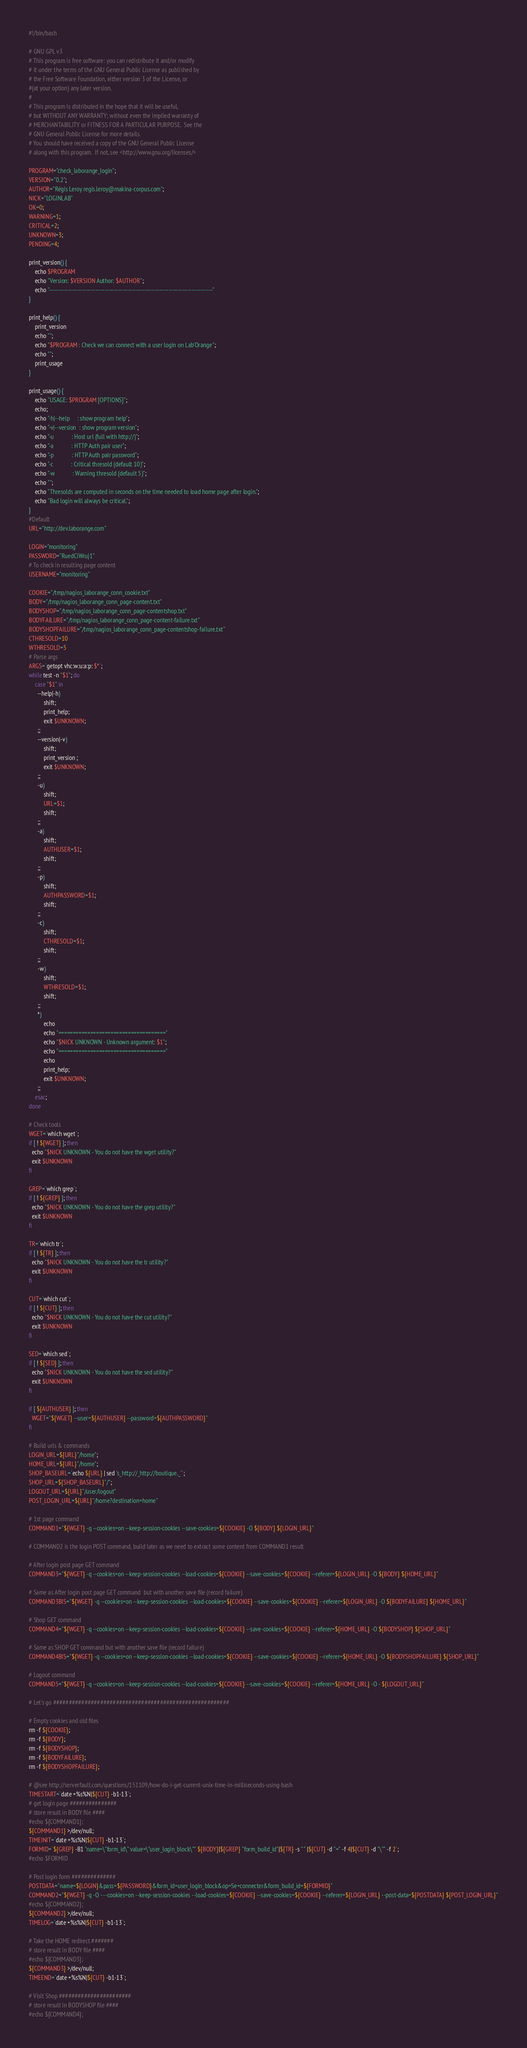<code> <loc_0><loc_0><loc_500><loc_500><_Bash_>#!/bin/bash

# GNU GPL v3
# This program is free software: you can redistribute it and/or modify
# it under the terms of the GNU General Public License as published by
# the Free Software Foundation, either version 3 of the License, or
#(at your option) any later version.
#
# This program is distributed in the hope that it will be useful,
# but WITHOUT ANY WARRANTY; without even the implied warranty of
# MERCHANTABILITY or FITNESS FOR A PARTICULAR PURPOSE.  See the
# GNU General Public License for more details.
# You should have received a copy of the GNU General Public License
# along with this program.  If not, see <http://www.gnu.org/licenses/>

PROGRAM="check_laborange_login";
VERSION="0.2";
AUTHOR="Régis Leroy regis.leroy@makina-corpus.com";
NICK="LOGINLAB"
OK=0;
WARNING=1;
CRITICAL=2;
UNKNOWN=3;
PENDING=4;

print_version() {
    echo $PROGRAM
    echo "Version: $VERSION Author: $AUTHOR";
    echo "-------------------------------------------------------------------------------------"
}

print_help() {
    print_version
    echo "";
    echo "$PROGRAM : Check we can connect with a user login on Lab'Orange";
    echo "";
    print_usage
}

print_usage() {
    echo "USAGE: $PROGRAM [OPTIONS]";
    echo;
    echo "-h|--help     : show program help";
    echo "-v|--version  : show program version";
    echo "-u            : Host url (full with http://)";
    echo "-a            : HTTP Auth pair user";
    echo "-p            : HTTP Auth pair password";
    echo "-c            : Critical thresold (default 10)";
    echo "-w            : Warning thresold (default 5)";
    echo "";
    echo "Thresolds are computed in seconds on the time needed to load home page after login.";
    echo "Bad login will always be critical.";
}
#Default
URL="http://dev.laborange.com"

LOGIN="monitoring"
PASSWORD="RuedCiWruj1"
# To check in resulting page content
USERNAME="monitoring"

COOKIE="/tmp/nagios_laborange_conn_cookie.txt"
BODY="/tmp/nagios_laborange_conn_page-content.txt"
BODYSHOP="/tmp/nagios_laborange_conn_page-contentshop.txt"
BODYFAILURE="/tmp/nagios_laborange_conn_page-content-failure.txt"
BODYSHOPFAILURE="/tmp/nagios_laborange_conn_page-contentshop-failure.txt"
CTHRESOLD=10
WTHRESOLD=5
# Parse args
ARGS=`getopt vhc:w:u:a:p: $*`;
while test -n "$1"; do
    case "$1" in
      --help|-h)
          shift;
          print_help;
          exit $UNKNOWN;
      ;;
      --version|-v)
          shift;
          print_version ;
          exit $UNKNOWN;
      ;;
      -u)
          shift;
          URL=$1;
          shift;
      ;;
      -a)
          shift;
          AUTHUSER=$1;
          shift;
      ;;
      -p)
          shift;
          AUTHPASSWORD=$1;
          shift;
      ;;
      -c)
          shift;
          CTHRESOLD=$1;
          shift;
      ;;
      -w)
          shift;
          WTHRESOLD=$1;
          shift;
      ;;
      *)
          echo 
          echo "====================================="
          echo "$NICK UNKNOWN - Unknown argument: $1";
          echo "====================================="
          echo
          print_help;
          exit $UNKNOWN;
      ;;
    esac;
done

# Check tools
WGET=`which wget`;
if [ ! ${WGET} ]; then
  echo "$NICK UNKNOWN - You do not have the wget utility?"
  exit $UNKNOWN
fi

GREP=`which grep`;
if [ ! ${GREP} ]; then
  echo "$NICK UNKNOWN - You do not have the grep utility?"
  exit $UNKNOWN
fi

TR=`which tr`;
if [ ! ${TR} ]; then
  echo "$NICK UNKNOWN - You do not have the tr utility?"
  exit $UNKNOWN
fi

CUT=`which cut`;
if [ ! ${CUT} ]; then
  echo "$NICK UNKNOWN - You do not have the cut utility?"
  exit $UNKNOWN
fi

SED=`which sed`;
if [ ! ${SED} ]; then
  echo "$NICK UNKNOWN - You do not have the sed utility?"
  exit $UNKNOWN
fi

if [ ${AUTHUSER} ]; then
  WGET="${WGET} --user=${AUTHUSER} --password=${AUTHPASSWORD}"
fi

# Build urls & commands
LOGIN_URL=${URL}"/home";
HOME_URL=${URL}"/home";
SHOP_BASEURL=`echo ${URL} | sed 's_http://_http://boutique._'`;
SHOP_URL=${SHOP_BASEURL}"/";
LOGOUT_URL=${URL}"/user/logout"
POST_LOGIN_URL=${URL}"/home?destination=home"

# 1st page command
COMMAND1="${WGET} -q --cookies=on --keep-session-cookies --save-cookies=${COOKIE} -O ${BODY} ${LOGIN_URL}"

# COMMAND2 is the login POST command, build later as we need to extract some content from COMMAND1 result

# After login post page GET command
COMMAND3="${WGET} -q --cookies=on --keep-session-cookies --load-cookies=${COOKIE} --save-cookies=${COOKIE} --referer=${LOGIN_URL} -O ${BODY} ${HOME_URL}"

# Same as After login post page GET command  but with another save file (record failure)
COMMAND3BIS="${WGET} -q --cookies=on --keep-session-cookies --load-cookies=${COOKIE} --save-cookies=${COOKIE} --referer=${LOGIN_URL} -O ${BODYFAILURE} ${HOME_URL}"

# Shop GET command
COMMAND4="${WGET} -q --cookies=on --keep-session-cookies --load-cookies=${COOKIE} --save-cookies=${COOKIE} --referer=${HOME_URL} -O ${BODYSHOP} ${SHOP_URL}"

# Same as SHOP GET command but with another save file (record failure)
COMMAND4BIS="${WGET} -q --cookies=on --keep-session-cookies --load-cookies=${COOKIE} --save-cookies=${COOKIE} --referer=${HOME_URL} -O ${BODYSHOPFAILURE} ${SHOP_URL}"

# Logout command
COMMAND5="${WGET} -q --cookies=on --keep-session-cookies --load-cookies=${COOKIE} --save-cookies=${COOKIE} --referer=${HOME_URL} -O - ${LOGOUT_URL}"

# Let's go ########################################################

# Empty cookies and old files
rm -f ${COOKIE};
rm -f ${BODY};
rm -f ${BODYSHOP};
rm -f ${BODYFAILURE};
rm -f ${BODYSHOPFAILURE};

# @see http://serverfault.com/questions/151109/how-do-i-get-current-unix-time-in-milliseconds-using-bash
TIMESTART=`date +%s%N|${CUT} -b1-13`;
# get login page ###############
# store result in BODY file ####
#echo ${COMMAND1};
${COMMAND1} >/dev/null;
TIMEINIT=`date +%s%N|${CUT} -b1-13`;
FORMID=`${GREP} -B1 "name=\"form_id\" value=\"user_login_block\"" ${BODY}|${GREP} "form_build_id"|${TR} -s " " |${CUT} -d "=" -f 4|${CUT} -d "\"" -f 2`;
#echo $FORMID

# Post login form ##############
POSTDATA="name=${LOGIN}&pass=${PASSWORD}&form_id=user_login_block&op=Se+connecter&form_build_id=${FORMID}"
COMMAND2="${WGET} -q -O - --cookies=on --keep-session-cookies --load-cookies=${COOKIE} --save-cookies=${COOKIE} --referer=${LOGIN_URL} --post-data=${POSTDATA} ${POST_LOGIN_URL}"
#echo ${COMMAND2};
${COMMAND2} >/dev/null;
TIMELOG=`date +%s%N|${CUT} -b1-13`;

# Take the HOME redirect #######
# store result in BODY file ####
#echo ${COMMAND3};
${COMMAND3} >/dev/null;
TIMEEND=`date +%s%N|${CUT} -b1-13`;

# Visit Shop #######################
# store result in BODYSHOP file ####
#echo ${COMMAND4};</code> 